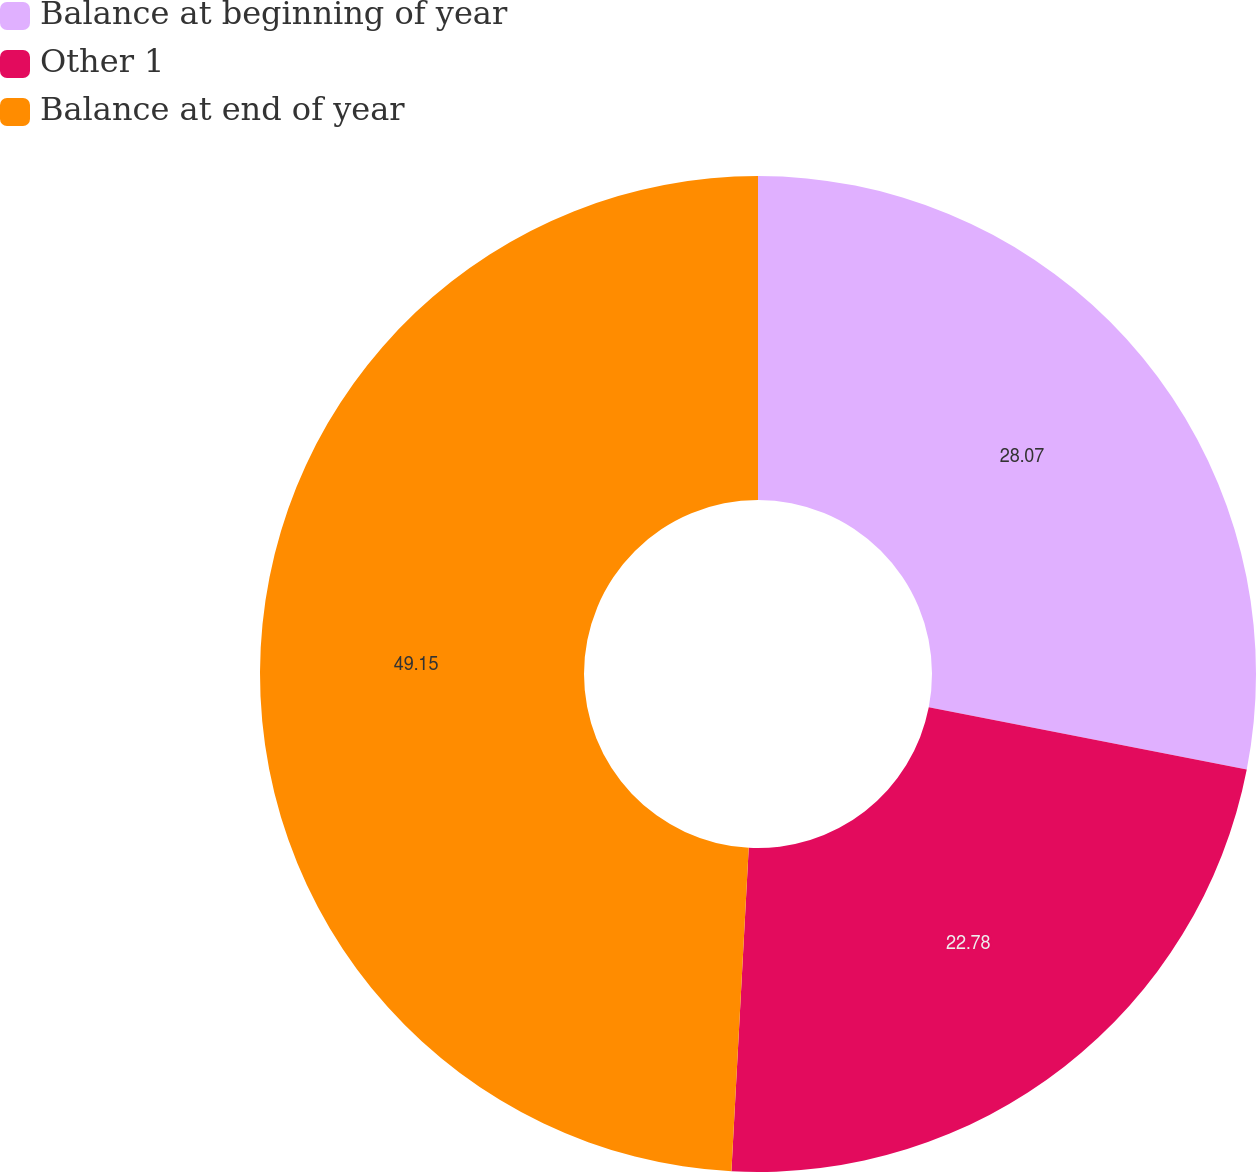<chart> <loc_0><loc_0><loc_500><loc_500><pie_chart><fcel>Balance at beginning of year<fcel>Other 1<fcel>Balance at end of year<nl><fcel>28.07%<fcel>22.78%<fcel>49.15%<nl></chart> 